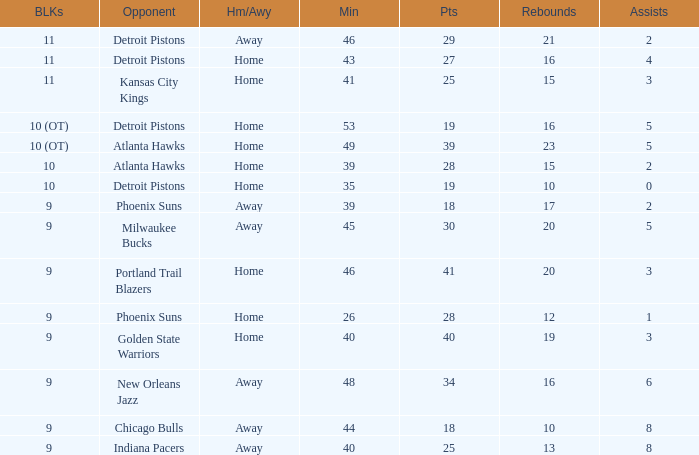How many minutes were played when there were 18 points and the opponent was Chicago Bulls? 1.0. 